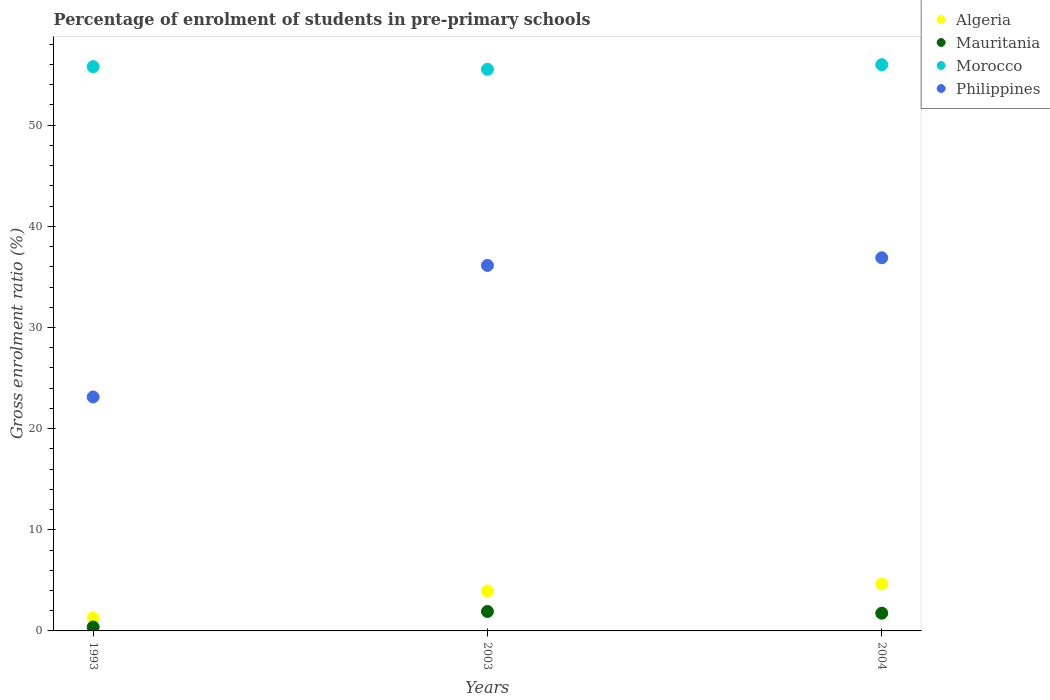How many different coloured dotlines are there?
Your answer should be very brief. 4. What is the percentage of students enrolled in pre-primary schools in Philippines in 1993?
Make the answer very short. 23.13. Across all years, what is the maximum percentage of students enrolled in pre-primary schools in Morocco?
Offer a terse response. 55.98. Across all years, what is the minimum percentage of students enrolled in pre-primary schools in Mauritania?
Make the answer very short. 0.39. In which year was the percentage of students enrolled in pre-primary schools in Philippines minimum?
Offer a very short reply. 1993. What is the total percentage of students enrolled in pre-primary schools in Morocco in the graph?
Offer a terse response. 167.29. What is the difference between the percentage of students enrolled in pre-primary schools in Algeria in 1993 and that in 2004?
Your answer should be compact. -3.35. What is the difference between the percentage of students enrolled in pre-primary schools in Morocco in 1993 and the percentage of students enrolled in pre-primary schools in Algeria in 2003?
Your response must be concise. 51.84. What is the average percentage of students enrolled in pre-primary schools in Morocco per year?
Make the answer very short. 55.76. In the year 1993, what is the difference between the percentage of students enrolled in pre-primary schools in Philippines and percentage of students enrolled in pre-primary schools in Algeria?
Provide a short and direct response. 21.84. In how many years, is the percentage of students enrolled in pre-primary schools in Philippines greater than 50 %?
Your answer should be compact. 0. What is the ratio of the percentage of students enrolled in pre-primary schools in Mauritania in 1993 to that in 2004?
Give a very brief answer. 0.22. What is the difference between the highest and the second highest percentage of students enrolled in pre-primary schools in Mauritania?
Ensure brevity in your answer.  0.17. What is the difference between the highest and the lowest percentage of students enrolled in pre-primary schools in Morocco?
Your response must be concise. 0.46. Is it the case that in every year, the sum of the percentage of students enrolled in pre-primary schools in Mauritania and percentage of students enrolled in pre-primary schools in Philippines  is greater than the sum of percentage of students enrolled in pre-primary schools in Algeria and percentage of students enrolled in pre-primary schools in Morocco?
Offer a terse response. Yes. Is it the case that in every year, the sum of the percentage of students enrolled in pre-primary schools in Mauritania and percentage of students enrolled in pre-primary schools in Philippines  is greater than the percentage of students enrolled in pre-primary schools in Morocco?
Your answer should be compact. No. Does the percentage of students enrolled in pre-primary schools in Algeria monotonically increase over the years?
Your response must be concise. Yes. Is the percentage of students enrolled in pre-primary schools in Philippines strictly greater than the percentage of students enrolled in pre-primary schools in Algeria over the years?
Keep it short and to the point. Yes. Is the percentage of students enrolled in pre-primary schools in Algeria strictly less than the percentage of students enrolled in pre-primary schools in Mauritania over the years?
Your response must be concise. No. Are the values on the major ticks of Y-axis written in scientific E-notation?
Keep it short and to the point. No. Does the graph contain grids?
Give a very brief answer. No. Where does the legend appear in the graph?
Give a very brief answer. Top right. How are the legend labels stacked?
Provide a short and direct response. Vertical. What is the title of the graph?
Provide a succinct answer. Percentage of enrolment of students in pre-primary schools. What is the Gross enrolment ratio (%) in Algeria in 1993?
Your answer should be compact. 1.29. What is the Gross enrolment ratio (%) of Mauritania in 1993?
Offer a very short reply. 0.39. What is the Gross enrolment ratio (%) of Morocco in 1993?
Your answer should be very brief. 55.79. What is the Gross enrolment ratio (%) of Philippines in 1993?
Keep it short and to the point. 23.13. What is the Gross enrolment ratio (%) of Algeria in 2003?
Provide a succinct answer. 3.95. What is the Gross enrolment ratio (%) of Mauritania in 2003?
Offer a very short reply. 1.92. What is the Gross enrolment ratio (%) of Morocco in 2003?
Offer a terse response. 55.52. What is the Gross enrolment ratio (%) in Philippines in 2003?
Keep it short and to the point. 36.13. What is the Gross enrolment ratio (%) in Algeria in 2004?
Your answer should be very brief. 4.64. What is the Gross enrolment ratio (%) of Mauritania in 2004?
Your answer should be very brief. 1.75. What is the Gross enrolment ratio (%) in Morocco in 2004?
Your answer should be compact. 55.98. What is the Gross enrolment ratio (%) of Philippines in 2004?
Your response must be concise. 36.89. Across all years, what is the maximum Gross enrolment ratio (%) of Algeria?
Make the answer very short. 4.64. Across all years, what is the maximum Gross enrolment ratio (%) in Mauritania?
Offer a very short reply. 1.92. Across all years, what is the maximum Gross enrolment ratio (%) in Morocco?
Your answer should be very brief. 55.98. Across all years, what is the maximum Gross enrolment ratio (%) of Philippines?
Offer a very short reply. 36.89. Across all years, what is the minimum Gross enrolment ratio (%) in Algeria?
Keep it short and to the point. 1.29. Across all years, what is the minimum Gross enrolment ratio (%) of Mauritania?
Your response must be concise. 0.39. Across all years, what is the minimum Gross enrolment ratio (%) of Morocco?
Keep it short and to the point. 55.52. Across all years, what is the minimum Gross enrolment ratio (%) in Philippines?
Offer a terse response. 23.13. What is the total Gross enrolment ratio (%) of Algeria in the graph?
Provide a short and direct response. 9.88. What is the total Gross enrolment ratio (%) of Mauritania in the graph?
Provide a short and direct response. 4.07. What is the total Gross enrolment ratio (%) of Morocco in the graph?
Offer a very short reply. 167.29. What is the total Gross enrolment ratio (%) of Philippines in the graph?
Give a very brief answer. 96.15. What is the difference between the Gross enrolment ratio (%) of Algeria in 1993 and that in 2003?
Keep it short and to the point. -2.67. What is the difference between the Gross enrolment ratio (%) of Mauritania in 1993 and that in 2003?
Offer a very short reply. -1.53. What is the difference between the Gross enrolment ratio (%) in Morocco in 1993 and that in 2003?
Provide a succinct answer. 0.26. What is the difference between the Gross enrolment ratio (%) in Philippines in 1993 and that in 2003?
Offer a terse response. -13.01. What is the difference between the Gross enrolment ratio (%) of Algeria in 1993 and that in 2004?
Provide a succinct answer. -3.35. What is the difference between the Gross enrolment ratio (%) in Mauritania in 1993 and that in 2004?
Your response must be concise. -1.37. What is the difference between the Gross enrolment ratio (%) in Morocco in 1993 and that in 2004?
Give a very brief answer. -0.19. What is the difference between the Gross enrolment ratio (%) of Philippines in 1993 and that in 2004?
Provide a short and direct response. -13.76. What is the difference between the Gross enrolment ratio (%) of Algeria in 2003 and that in 2004?
Make the answer very short. -0.69. What is the difference between the Gross enrolment ratio (%) of Mauritania in 2003 and that in 2004?
Provide a succinct answer. 0.17. What is the difference between the Gross enrolment ratio (%) in Morocco in 2003 and that in 2004?
Provide a succinct answer. -0.46. What is the difference between the Gross enrolment ratio (%) in Philippines in 2003 and that in 2004?
Give a very brief answer. -0.75. What is the difference between the Gross enrolment ratio (%) of Algeria in 1993 and the Gross enrolment ratio (%) of Mauritania in 2003?
Provide a succinct answer. -0.64. What is the difference between the Gross enrolment ratio (%) in Algeria in 1993 and the Gross enrolment ratio (%) in Morocco in 2003?
Your response must be concise. -54.24. What is the difference between the Gross enrolment ratio (%) in Algeria in 1993 and the Gross enrolment ratio (%) in Philippines in 2003?
Provide a succinct answer. -34.85. What is the difference between the Gross enrolment ratio (%) of Mauritania in 1993 and the Gross enrolment ratio (%) of Morocco in 2003?
Offer a terse response. -55.14. What is the difference between the Gross enrolment ratio (%) in Mauritania in 1993 and the Gross enrolment ratio (%) in Philippines in 2003?
Ensure brevity in your answer.  -35.75. What is the difference between the Gross enrolment ratio (%) in Morocco in 1993 and the Gross enrolment ratio (%) in Philippines in 2003?
Your response must be concise. 19.65. What is the difference between the Gross enrolment ratio (%) of Algeria in 1993 and the Gross enrolment ratio (%) of Mauritania in 2004?
Your answer should be compact. -0.47. What is the difference between the Gross enrolment ratio (%) of Algeria in 1993 and the Gross enrolment ratio (%) of Morocco in 2004?
Keep it short and to the point. -54.69. What is the difference between the Gross enrolment ratio (%) in Algeria in 1993 and the Gross enrolment ratio (%) in Philippines in 2004?
Make the answer very short. -35.6. What is the difference between the Gross enrolment ratio (%) in Mauritania in 1993 and the Gross enrolment ratio (%) in Morocco in 2004?
Provide a succinct answer. -55.59. What is the difference between the Gross enrolment ratio (%) in Mauritania in 1993 and the Gross enrolment ratio (%) in Philippines in 2004?
Ensure brevity in your answer.  -36.5. What is the difference between the Gross enrolment ratio (%) in Morocco in 1993 and the Gross enrolment ratio (%) in Philippines in 2004?
Provide a short and direct response. 18.9. What is the difference between the Gross enrolment ratio (%) of Algeria in 2003 and the Gross enrolment ratio (%) of Mauritania in 2004?
Your answer should be compact. 2.2. What is the difference between the Gross enrolment ratio (%) of Algeria in 2003 and the Gross enrolment ratio (%) of Morocco in 2004?
Offer a very short reply. -52.03. What is the difference between the Gross enrolment ratio (%) of Algeria in 2003 and the Gross enrolment ratio (%) of Philippines in 2004?
Your answer should be compact. -32.94. What is the difference between the Gross enrolment ratio (%) in Mauritania in 2003 and the Gross enrolment ratio (%) in Morocco in 2004?
Ensure brevity in your answer.  -54.06. What is the difference between the Gross enrolment ratio (%) in Mauritania in 2003 and the Gross enrolment ratio (%) in Philippines in 2004?
Keep it short and to the point. -34.96. What is the difference between the Gross enrolment ratio (%) in Morocco in 2003 and the Gross enrolment ratio (%) in Philippines in 2004?
Ensure brevity in your answer.  18.64. What is the average Gross enrolment ratio (%) of Algeria per year?
Provide a succinct answer. 3.29. What is the average Gross enrolment ratio (%) in Mauritania per year?
Offer a very short reply. 1.36. What is the average Gross enrolment ratio (%) in Morocco per year?
Offer a terse response. 55.76. What is the average Gross enrolment ratio (%) of Philippines per year?
Keep it short and to the point. 32.05. In the year 1993, what is the difference between the Gross enrolment ratio (%) of Algeria and Gross enrolment ratio (%) of Mauritania?
Ensure brevity in your answer.  0.9. In the year 1993, what is the difference between the Gross enrolment ratio (%) of Algeria and Gross enrolment ratio (%) of Morocco?
Your response must be concise. -54.5. In the year 1993, what is the difference between the Gross enrolment ratio (%) in Algeria and Gross enrolment ratio (%) in Philippines?
Make the answer very short. -21.84. In the year 1993, what is the difference between the Gross enrolment ratio (%) in Mauritania and Gross enrolment ratio (%) in Morocco?
Your response must be concise. -55.4. In the year 1993, what is the difference between the Gross enrolment ratio (%) of Mauritania and Gross enrolment ratio (%) of Philippines?
Make the answer very short. -22.74. In the year 1993, what is the difference between the Gross enrolment ratio (%) in Morocco and Gross enrolment ratio (%) in Philippines?
Offer a terse response. 32.66. In the year 2003, what is the difference between the Gross enrolment ratio (%) of Algeria and Gross enrolment ratio (%) of Mauritania?
Give a very brief answer. 2.03. In the year 2003, what is the difference between the Gross enrolment ratio (%) of Algeria and Gross enrolment ratio (%) of Morocco?
Provide a short and direct response. -51.57. In the year 2003, what is the difference between the Gross enrolment ratio (%) in Algeria and Gross enrolment ratio (%) in Philippines?
Your answer should be very brief. -32.18. In the year 2003, what is the difference between the Gross enrolment ratio (%) of Mauritania and Gross enrolment ratio (%) of Morocco?
Make the answer very short. -53.6. In the year 2003, what is the difference between the Gross enrolment ratio (%) in Mauritania and Gross enrolment ratio (%) in Philippines?
Offer a terse response. -34.21. In the year 2003, what is the difference between the Gross enrolment ratio (%) of Morocco and Gross enrolment ratio (%) of Philippines?
Make the answer very short. 19.39. In the year 2004, what is the difference between the Gross enrolment ratio (%) in Algeria and Gross enrolment ratio (%) in Mauritania?
Your answer should be compact. 2.89. In the year 2004, what is the difference between the Gross enrolment ratio (%) of Algeria and Gross enrolment ratio (%) of Morocco?
Your answer should be very brief. -51.34. In the year 2004, what is the difference between the Gross enrolment ratio (%) in Algeria and Gross enrolment ratio (%) in Philippines?
Give a very brief answer. -32.25. In the year 2004, what is the difference between the Gross enrolment ratio (%) in Mauritania and Gross enrolment ratio (%) in Morocco?
Keep it short and to the point. -54.23. In the year 2004, what is the difference between the Gross enrolment ratio (%) in Mauritania and Gross enrolment ratio (%) in Philippines?
Your answer should be very brief. -35.13. In the year 2004, what is the difference between the Gross enrolment ratio (%) in Morocco and Gross enrolment ratio (%) in Philippines?
Give a very brief answer. 19.09. What is the ratio of the Gross enrolment ratio (%) of Algeria in 1993 to that in 2003?
Provide a short and direct response. 0.33. What is the ratio of the Gross enrolment ratio (%) of Mauritania in 1993 to that in 2003?
Give a very brief answer. 0.2. What is the ratio of the Gross enrolment ratio (%) of Morocco in 1993 to that in 2003?
Provide a short and direct response. 1. What is the ratio of the Gross enrolment ratio (%) of Philippines in 1993 to that in 2003?
Ensure brevity in your answer.  0.64. What is the ratio of the Gross enrolment ratio (%) in Algeria in 1993 to that in 2004?
Ensure brevity in your answer.  0.28. What is the ratio of the Gross enrolment ratio (%) in Mauritania in 1993 to that in 2004?
Provide a succinct answer. 0.22. What is the ratio of the Gross enrolment ratio (%) of Philippines in 1993 to that in 2004?
Provide a short and direct response. 0.63. What is the ratio of the Gross enrolment ratio (%) in Algeria in 2003 to that in 2004?
Provide a short and direct response. 0.85. What is the ratio of the Gross enrolment ratio (%) of Mauritania in 2003 to that in 2004?
Your answer should be compact. 1.1. What is the ratio of the Gross enrolment ratio (%) in Philippines in 2003 to that in 2004?
Keep it short and to the point. 0.98. What is the difference between the highest and the second highest Gross enrolment ratio (%) in Algeria?
Your answer should be compact. 0.69. What is the difference between the highest and the second highest Gross enrolment ratio (%) of Mauritania?
Give a very brief answer. 0.17. What is the difference between the highest and the second highest Gross enrolment ratio (%) of Morocco?
Provide a succinct answer. 0.19. What is the difference between the highest and the second highest Gross enrolment ratio (%) of Philippines?
Your answer should be compact. 0.75. What is the difference between the highest and the lowest Gross enrolment ratio (%) of Algeria?
Offer a very short reply. 3.35. What is the difference between the highest and the lowest Gross enrolment ratio (%) of Mauritania?
Offer a terse response. 1.53. What is the difference between the highest and the lowest Gross enrolment ratio (%) of Morocco?
Provide a succinct answer. 0.46. What is the difference between the highest and the lowest Gross enrolment ratio (%) in Philippines?
Your answer should be compact. 13.76. 